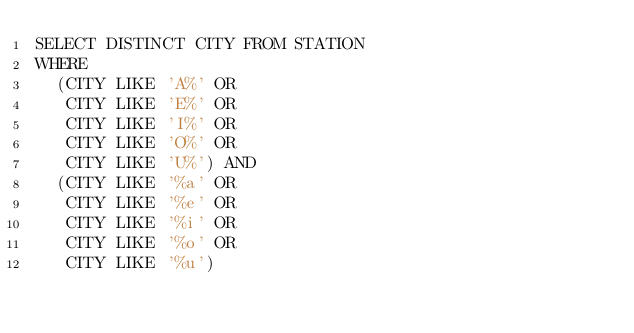<code> <loc_0><loc_0><loc_500><loc_500><_SQL_>SELECT DISTINCT CITY FROM STATION
WHERE
  (CITY LIKE 'A%' OR
   CITY LIKE 'E%' OR
   CITY LIKE 'I%' OR
   CITY LIKE 'O%' OR
   CITY LIKE 'U%') AND
  (CITY LIKE '%a' OR
   CITY LIKE '%e' OR
   CITY LIKE '%i' OR
   CITY LIKE '%o' OR
   CITY LIKE '%u')</code> 